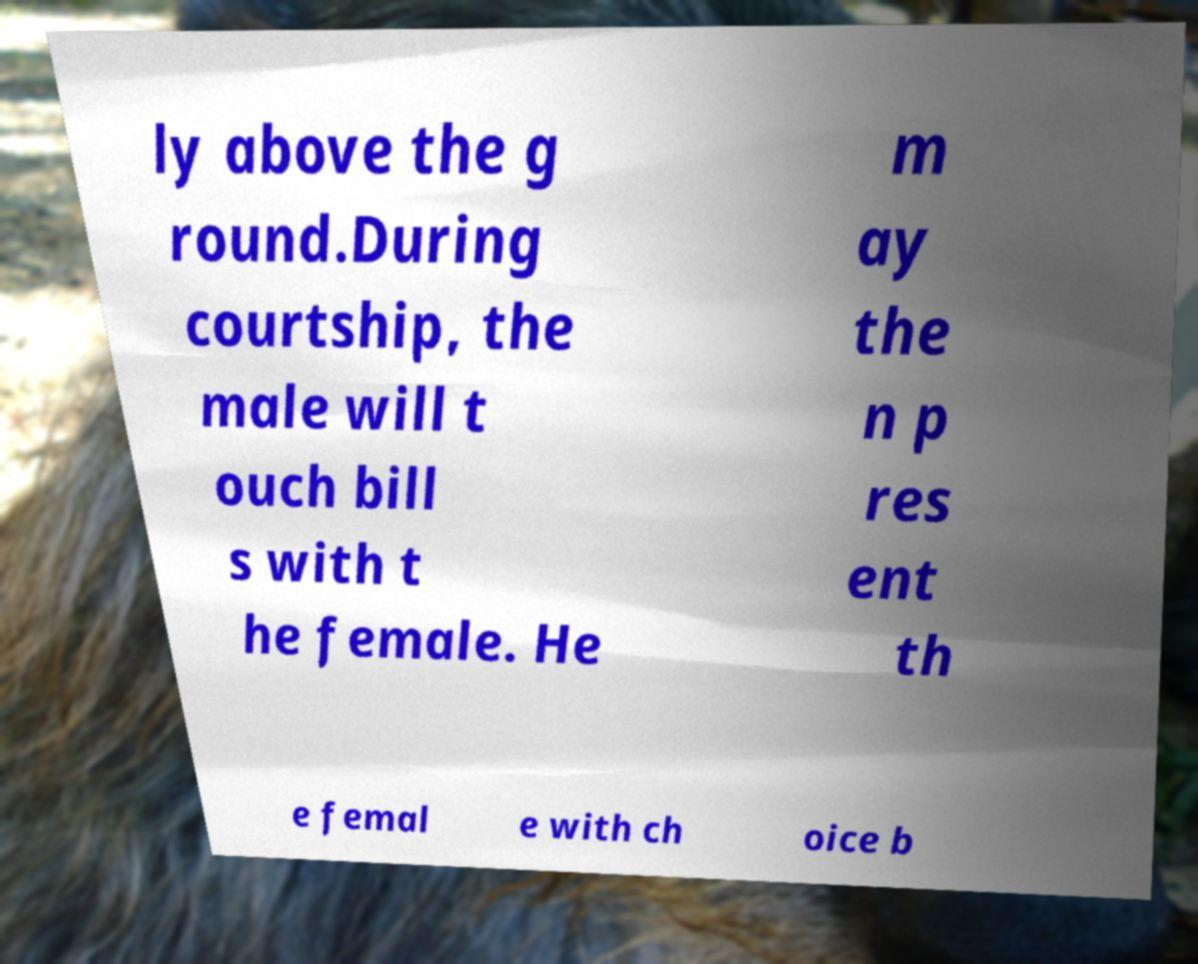For documentation purposes, I need the text within this image transcribed. Could you provide that? ly above the g round.During courtship, the male will t ouch bill s with t he female. He m ay the n p res ent th e femal e with ch oice b 